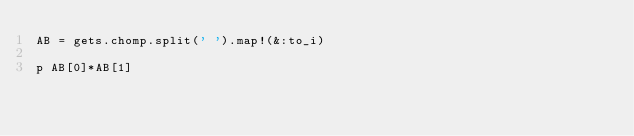Convert code to text. <code><loc_0><loc_0><loc_500><loc_500><_Ruby_>AB = gets.chomp.split(' ').map!(&:to_i)

p AB[0]*AB[1]
</code> 